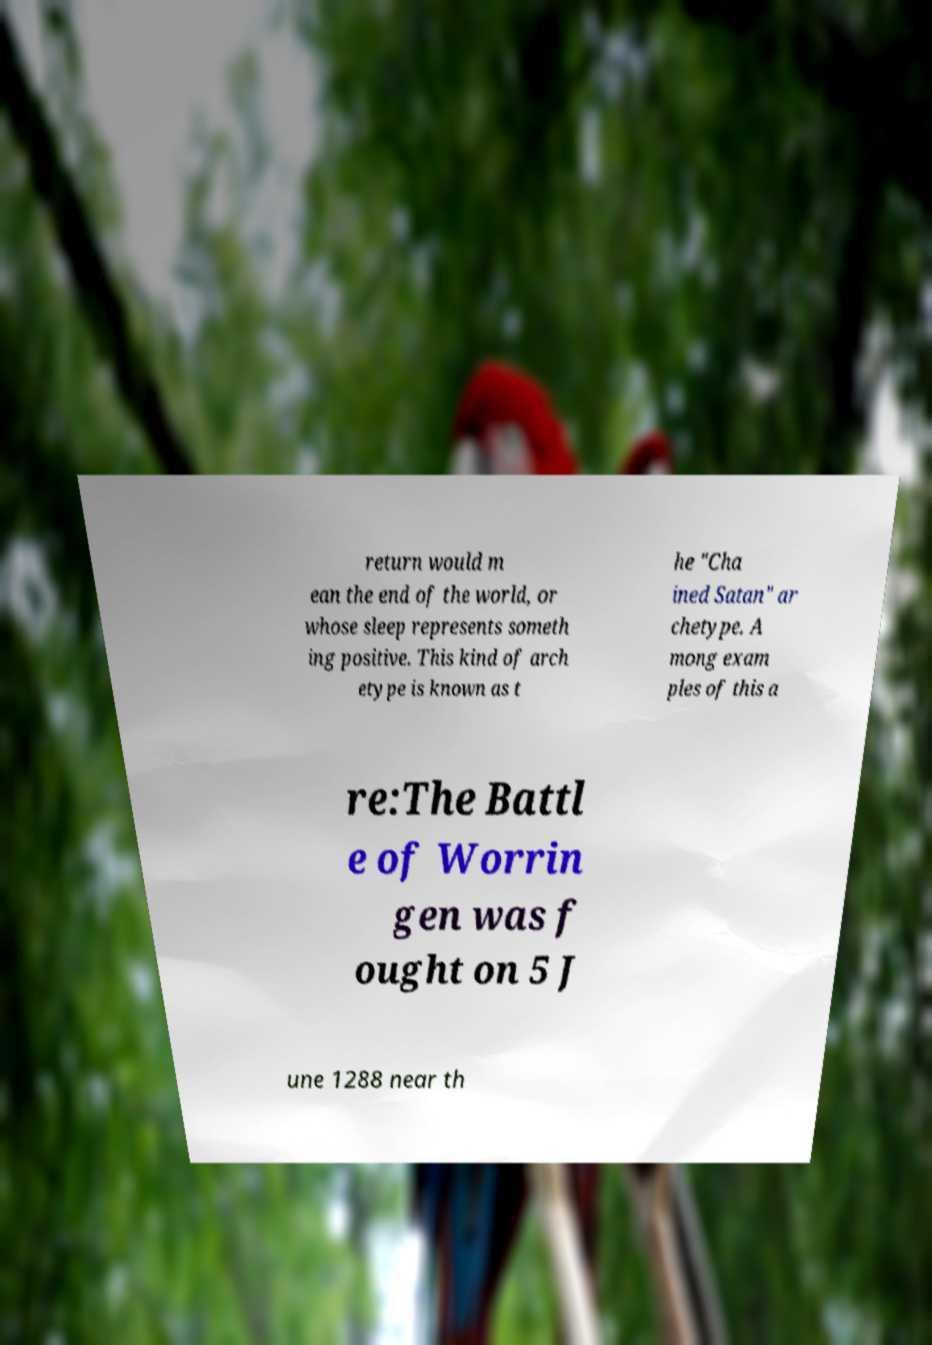Can you accurately transcribe the text from the provided image for me? return would m ean the end of the world, or whose sleep represents someth ing positive. This kind of arch etype is known as t he "Cha ined Satan" ar chetype. A mong exam ples of this a re:The Battl e of Worrin gen was f ought on 5 J une 1288 near th 